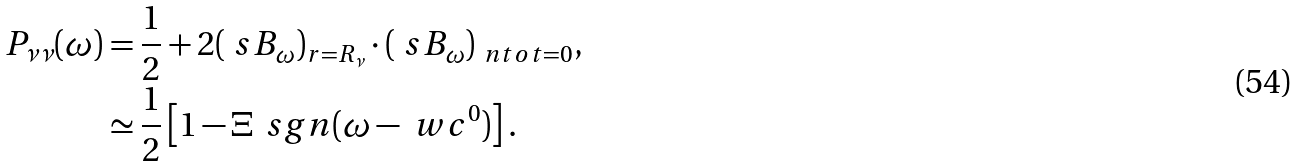<formula> <loc_0><loc_0><loc_500><loc_500>P _ { \nu \nu } ( \omega ) & = \frac { 1 } { 2 } + 2 ( \ s B _ { \omega } ) _ { r = R _ { \nu } } \cdot ( \ s B _ { \omega } ) _ { \ n t o t = 0 } , \\ & \simeq \frac { 1 } { 2 } \left [ 1 - \Xi \, \ s g n ( \omega - \ w c ^ { 0 } ) \right ] .</formula> 